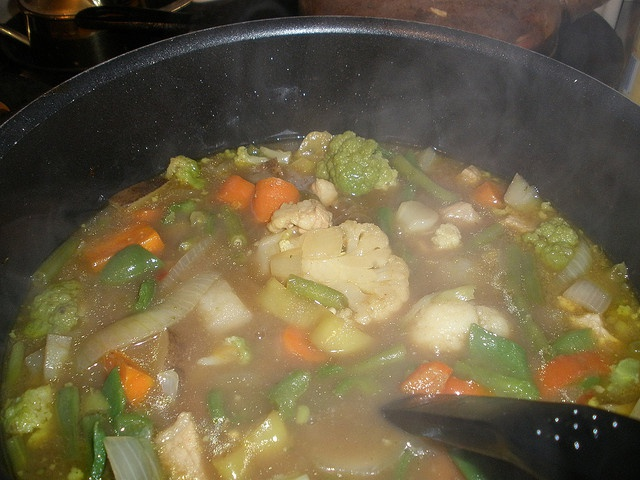Describe the objects in this image and their specific colors. I can see bowl in black, tan, gray, and olive tones, spoon in black and gray tones, broccoli in black and tan tones, broccoli in black, olive, and gray tones, and broccoli in black and tan tones in this image. 